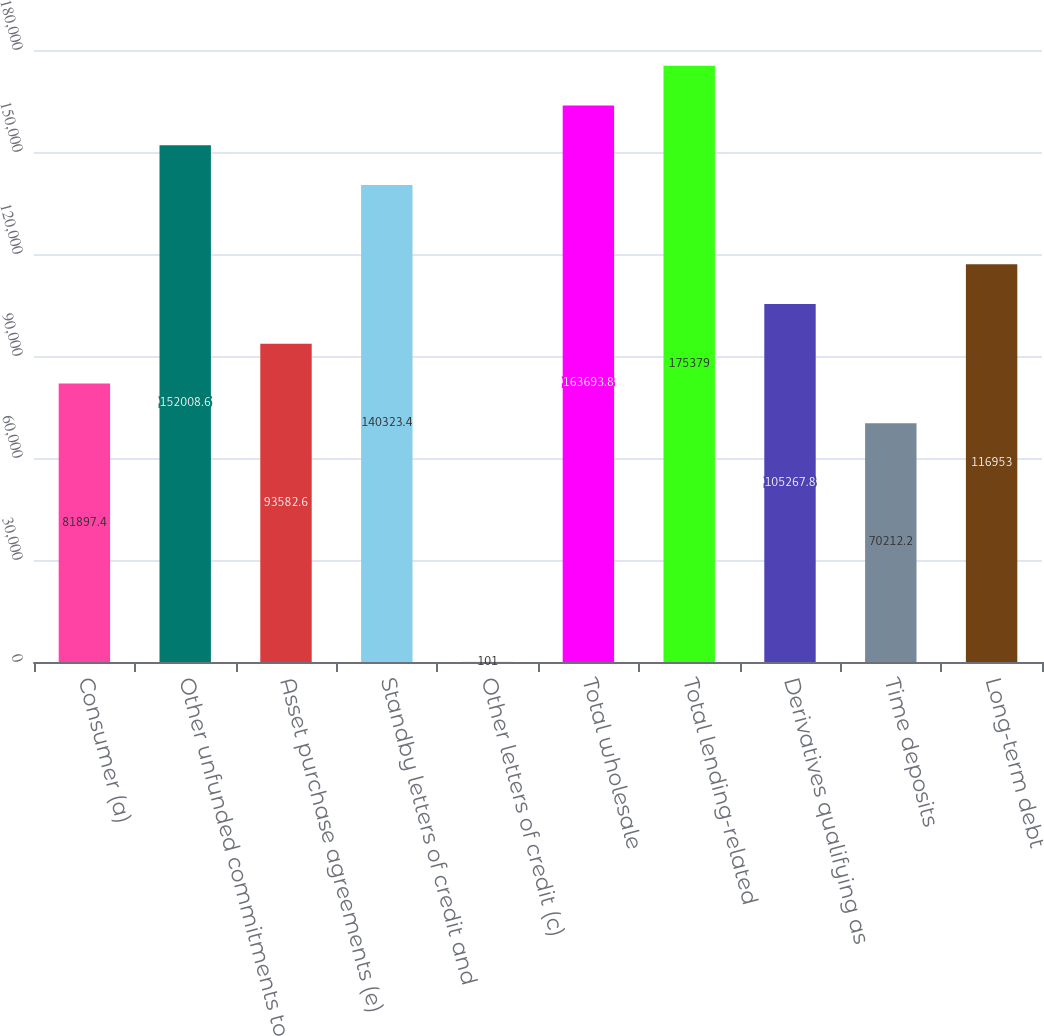Convert chart to OTSL. <chart><loc_0><loc_0><loc_500><loc_500><bar_chart><fcel>Consumer (a)<fcel>Other unfunded commitments to<fcel>Asset purchase agreements (e)<fcel>Standby letters of credit and<fcel>Other letters of credit (c)<fcel>Total wholesale<fcel>Total lending-related<fcel>Derivatives qualifying as<fcel>Time deposits<fcel>Long-term debt<nl><fcel>81897.4<fcel>152009<fcel>93582.6<fcel>140323<fcel>101<fcel>163694<fcel>175379<fcel>105268<fcel>70212.2<fcel>116953<nl></chart> 